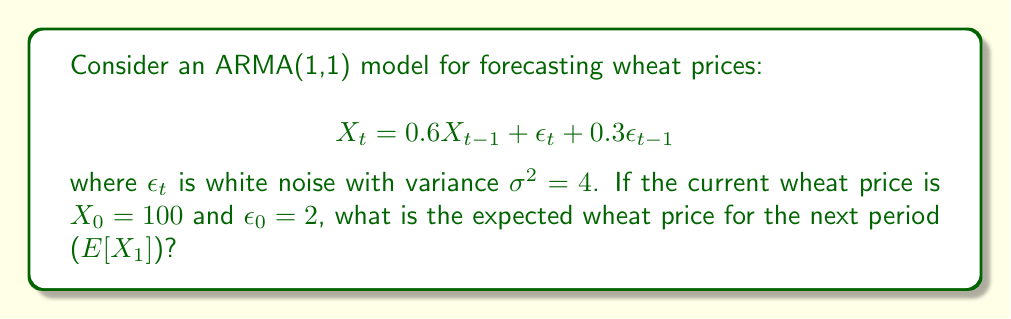What is the answer to this math problem? To solve this problem, we'll follow these steps:

1) The ARMA(1,1) model is given by:
   $$X_t = 0.6X_{t-1} + \epsilon_t + 0.3\epsilon_{t-1}$$

2) We need to find $E[X_1]$. Let's expand the equation for $t=1$:
   $$X_1 = 0.6X_0 + \epsilon_1 + 0.3\epsilon_0$$

3) Now, let's take the expectation of both sides:
   $$E[X_1] = E[0.6X_0 + \epsilon_1 + 0.3\epsilon_0]$$

4) Using the linearity of expectation:
   $$E[X_1] = 0.6E[X_0] + E[\epsilon_1] + 0.3E[\epsilon_0]$$

5) We know that:
   - $X_0 = 100$ (given)
   - $E[\epsilon_1] = 0$ (white noise has zero mean)
   - $\epsilon_0 = 2$ (given)

6) Substituting these values:
   $$E[X_1] = 0.6(100) + 0 + 0.3(2)$$

7) Calculating:
   $$E[X_1] = 60 + 0.6 = 60.6$$

Therefore, the expected wheat price for the next period is 60.6.
Answer: 60.6 